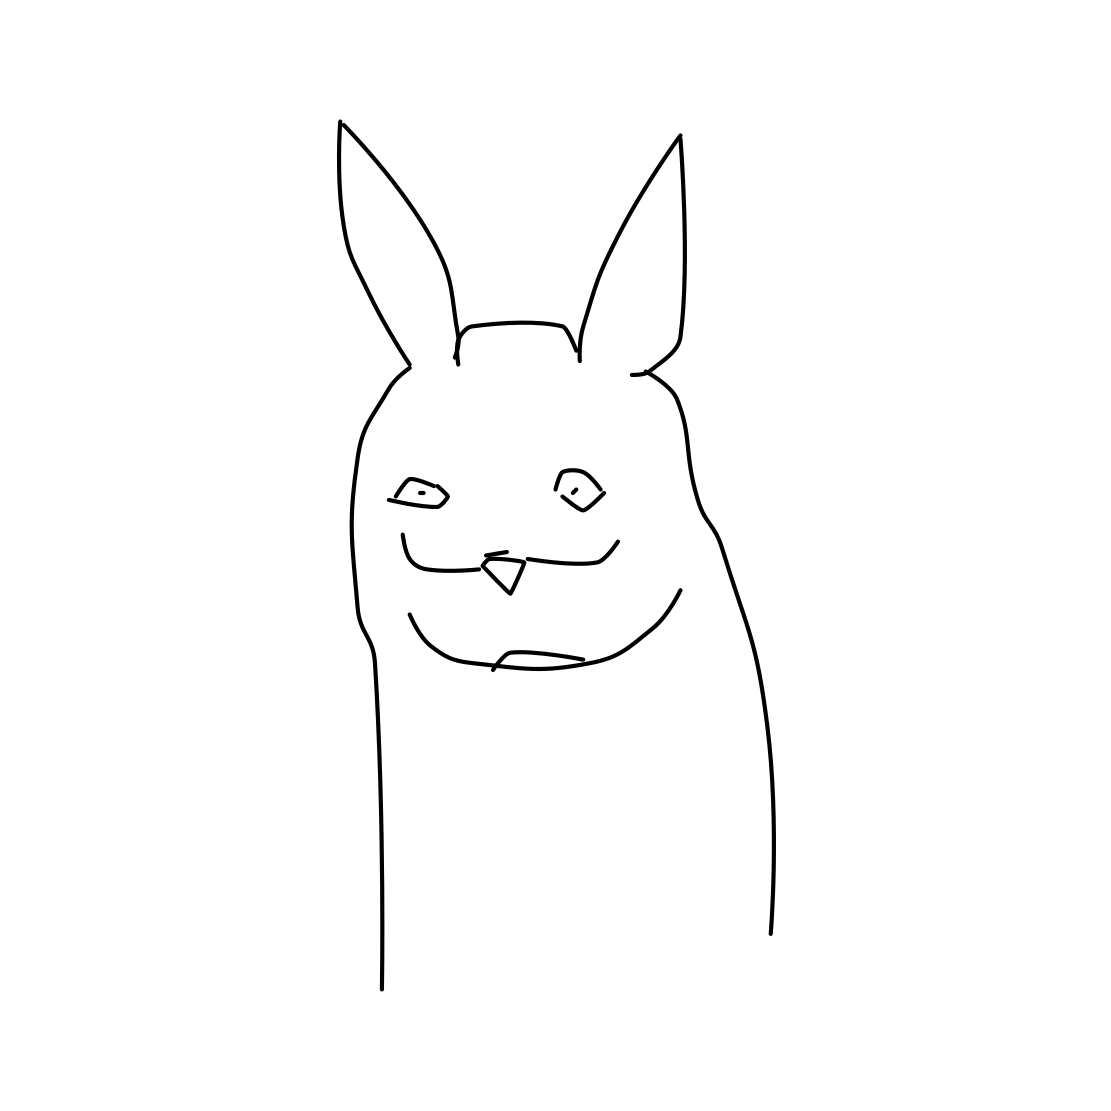Is there a sketchy crown in the picture? No 